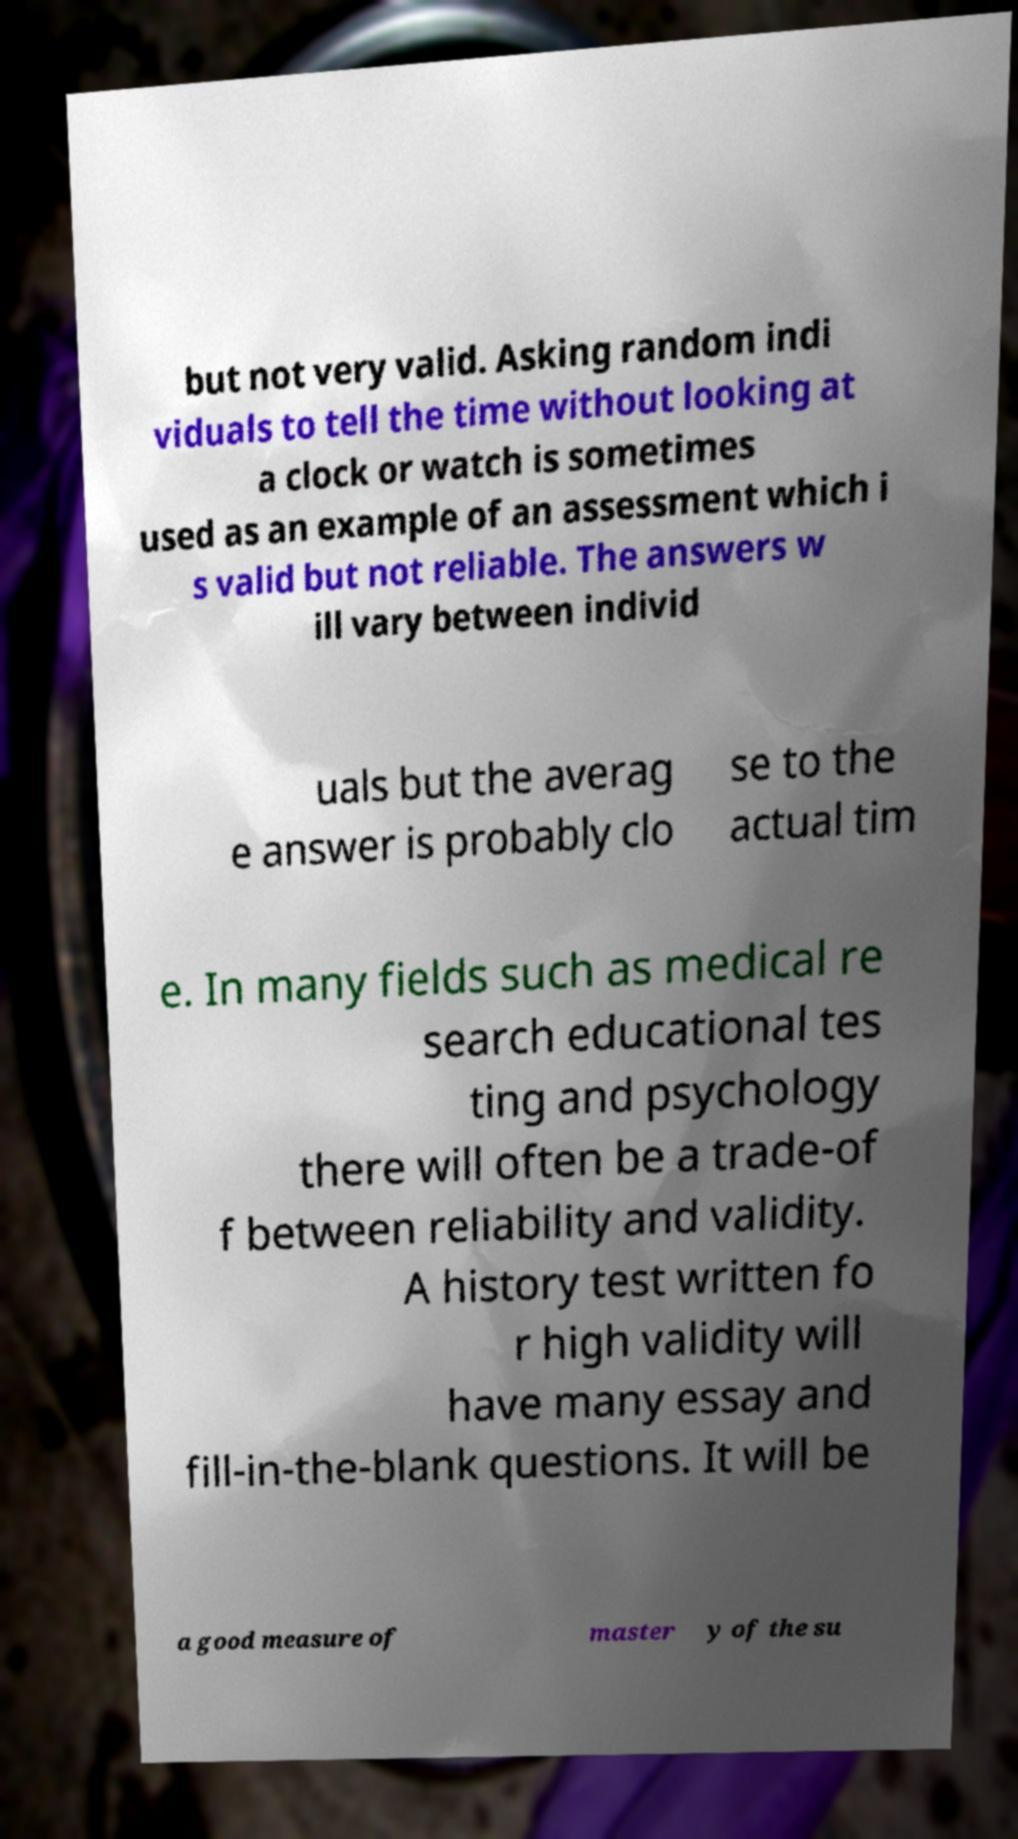Please identify and transcribe the text found in this image. but not very valid. Asking random indi viduals to tell the time without looking at a clock or watch is sometimes used as an example of an assessment which i s valid but not reliable. The answers w ill vary between individ uals but the averag e answer is probably clo se to the actual tim e. In many fields such as medical re search educational tes ting and psychology there will often be a trade-of f between reliability and validity. A history test written fo r high validity will have many essay and fill-in-the-blank questions. It will be a good measure of master y of the su 